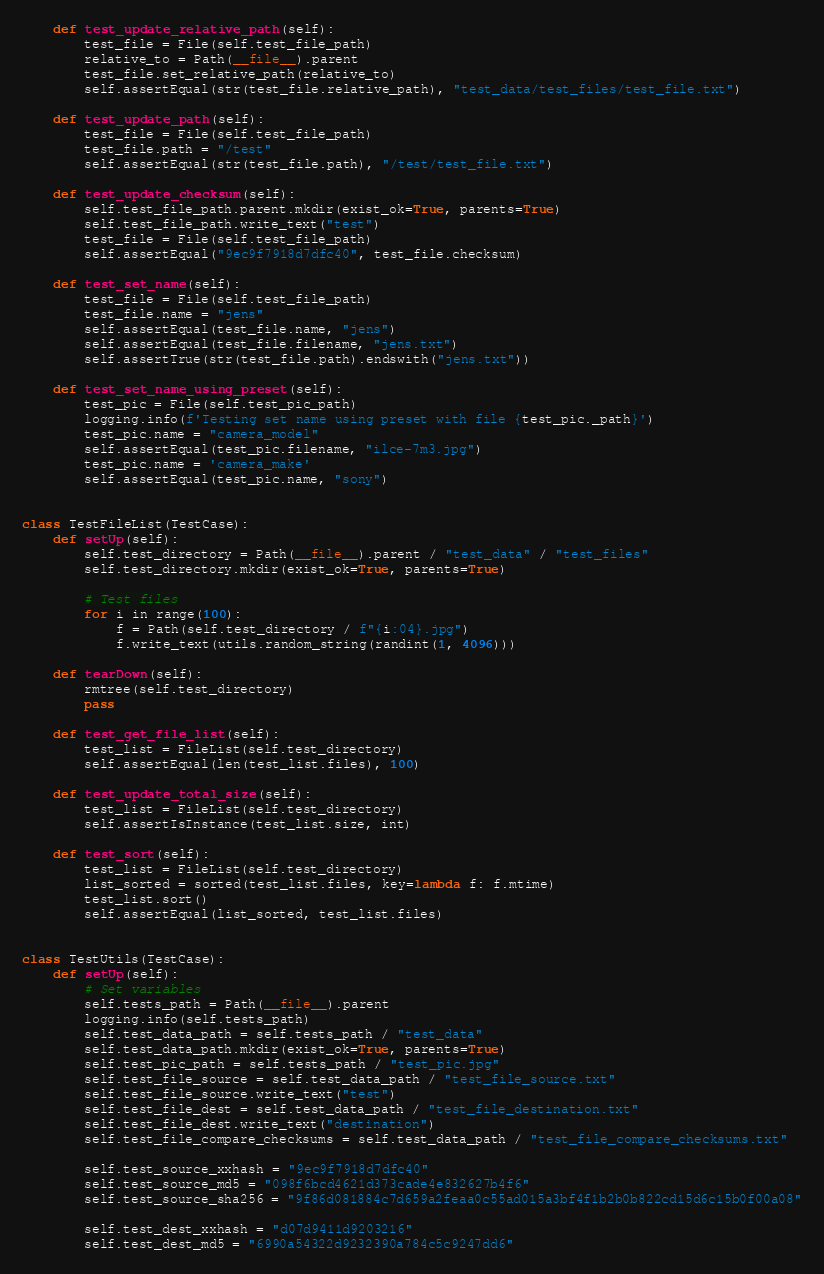<code> <loc_0><loc_0><loc_500><loc_500><_Python_>
    def test_update_relative_path(self):
        test_file = File(self.test_file_path)
        relative_to = Path(__file__).parent
        test_file.set_relative_path(relative_to)
        self.assertEqual(str(test_file.relative_path), "test_data/test_files/test_file.txt")

    def test_update_path(self):
        test_file = File(self.test_file_path)
        test_file.path = "/test"
        self.assertEqual(str(test_file.path), "/test/test_file.txt")

    def test_update_checksum(self):
        self.test_file_path.parent.mkdir(exist_ok=True, parents=True)
        self.test_file_path.write_text("test")
        test_file = File(self.test_file_path)
        self.assertEqual("9ec9f7918d7dfc40", test_file.checksum)

    def test_set_name(self):
        test_file = File(self.test_file_path)
        test_file.name = "jens"
        self.assertEqual(test_file.name, "jens")
        self.assertEqual(test_file.filename, "jens.txt")
        self.assertTrue(str(test_file.path).endswith("jens.txt"))

    def test_set_name_using_preset(self):
        test_pic = File(self.test_pic_path)
        logging.info(f'Testing set name using preset with file {test_pic._path}')
        test_pic.name = "camera_model"
        self.assertEqual(test_pic.filename, "ilce-7m3.jpg")
        test_pic.name = 'camera_make'
        self.assertEqual(test_pic.name, "sony")


class TestFileList(TestCase):
    def setUp(self):
        self.test_directory = Path(__file__).parent / "test_data" / "test_files"
        self.test_directory.mkdir(exist_ok=True, parents=True)

        # Test files
        for i in range(100):
            f = Path(self.test_directory / f"{i:04}.jpg")
            f.write_text(utils.random_string(randint(1, 4096)))

    def tearDown(self):
        rmtree(self.test_directory)
        pass

    def test_get_file_list(self):
        test_list = FileList(self.test_directory)
        self.assertEqual(len(test_list.files), 100)

    def test_update_total_size(self):
        test_list = FileList(self.test_directory)
        self.assertIsInstance(test_list.size, int)

    def test_sort(self):
        test_list = FileList(self.test_directory)
        list_sorted = sorted(test_list.files, key=lambda f: f.mtime)
        test_list.sort()
        self.assertEqual(list_sorted, test_list.files)


class TestUtils(TestCase):
    def setUp(self):
        # Set variables
        self.tests_path = Path(__file__).parent
        logging.info(self.tests_path)
        self.test_data_path = self.tests_path / "test_data"
        self.test_data_path.mkdir(exist_ok=True, parents=True)
        self.test_pic_path = self.tests_path / "test_pic.jpg"
        self.test_file_source = self.test_data_path / "test_file_source.txt"
        self.test_file_source.write_text("test")
        self.test_file_dest = self.test_data_path / "test_file_destination.txt"
        self.test_file_dest.write_text("destination")
        self.test_file_compare_checksums = self.test_data_path / "test_file_compare_checksums.txt"

        self.test_source_xxhash = "9ec9f7918d7dfc40"
        self.test_source_md5 = "098f6bcd4621d373cade4e832627b4f6"
        self.test_source_sha256 = "9f86d081884c7d659a2feaa0c55ad015a3bf4f1b2b0b822cd15d6c15b0f00a08"

        self.test_dest_xxhash = "d07d9411d9203216"
        self.test_dest_md5 = "6990a54322d9232390a784c5c9247dd6"</code> 